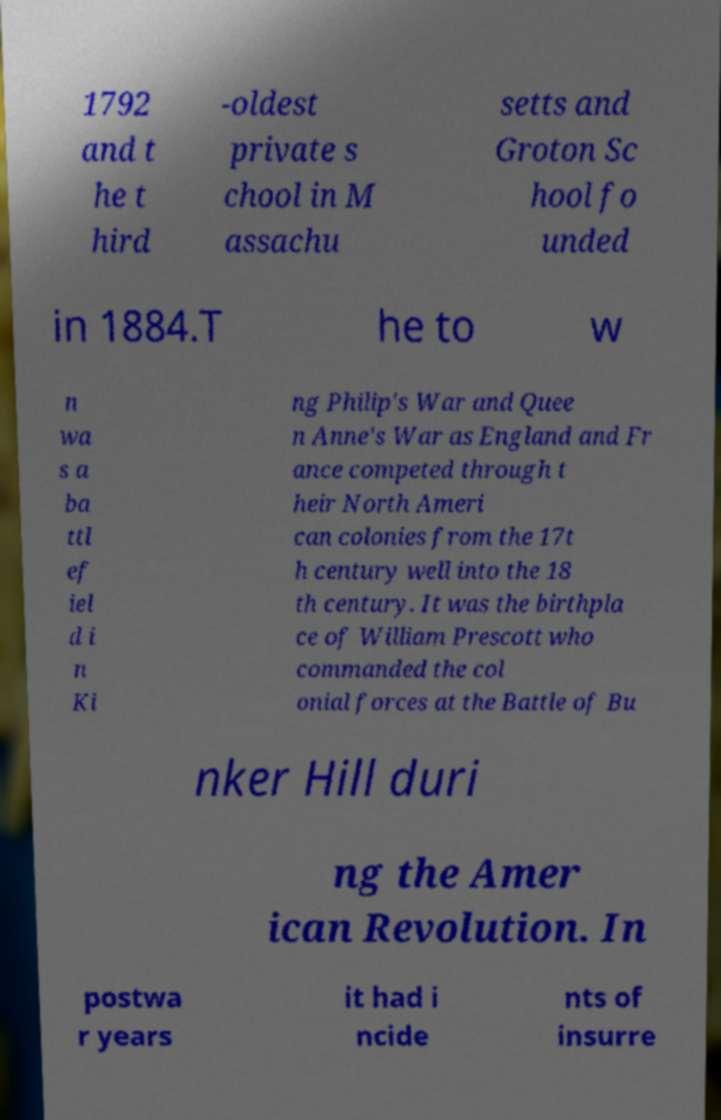Could you extract and type out the text from this image? 1792 and t he t hird -oldest private s chool in M assachu setts and Groton Sc hool fo unded in 1884.T he to w n wa s a ba ttl ef iel d i n Ki ng Philip's War and Quee n Anne's War as England and Fr ance competed through t heir North Ameri can colonies from the 17t h century well into the 18 th century. It was the birthpla ce of William Prescott who commanded the col onial forces at the Battle of Bu nker Hill duri ng the Amer ican Revolution. In postwa r years it had i ncide nts of insurre 